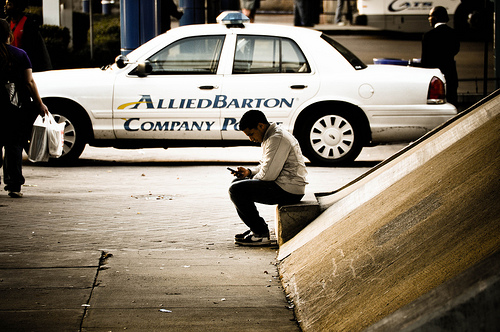Is the bag on the right side or on the left? The bag is positioned on the left side of the image, near the man sitting on the bench. 